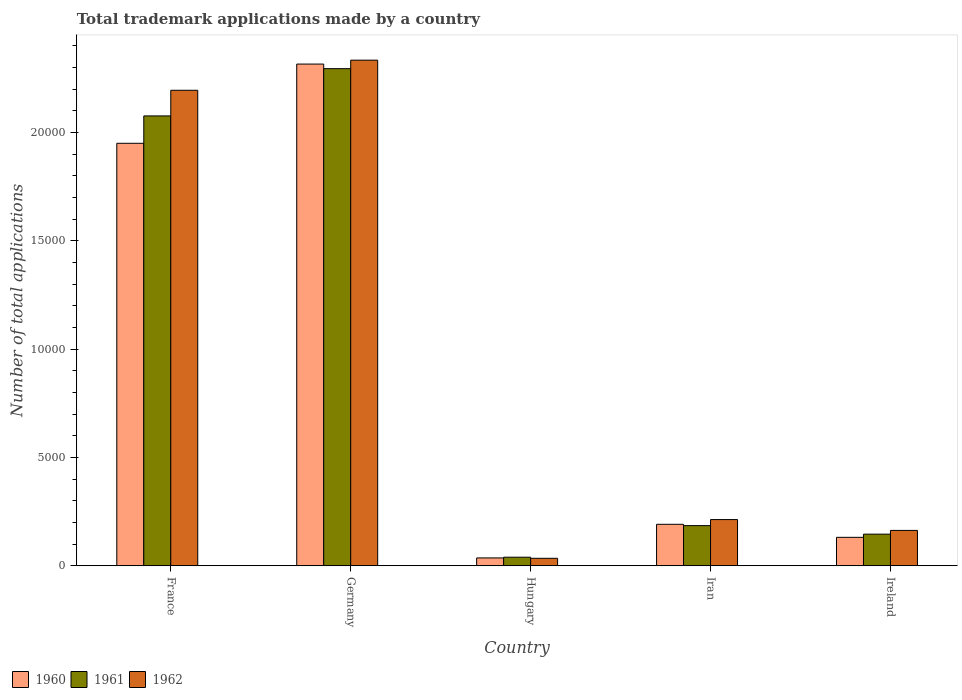How many different coloured bars are there?
Your answer should be very brief. 3. How many groups of bars are there?
Ensure brevity in your answer.  5. Are the number of bars on each tick of the X-axis equal?
Your answer should be compact. Yes. How many bars are there on the 2nd tick from the right?
Your answer should be very brief. 3. What is the number of applications made by in 1962 in Ireland?
Your response must be concise. 1633. Across all countries, what is the maximum number of applications made by in 1962?
Ensure brevity in your answer.  2.33e+04. Across all countries, what is the minimum number of applications made by in 1960?
Your response must be concise. 363. In which country was the number of applications made by in 1960 minimum?
Ensure brevity in your answer.  Hungary. What is the total number of applications made by in 1962 in the graph?
Provide a succinct answer. 4.94e+04. What is the difference between the number of applications made by in 1960 in Germany and that in Ireland?
Give a very brief answer. 2.18e+04. What is the difference between the number of applications made by in 1960 in Ireland and the number of applications made by in 1961 in France?
Ensure brevity in your answer.  -1.95e+04. What is the average number of applications made by in 1962 per country?
Make the answer very short. 9881.4. What is the difference between the number of applications made by of/in 1960 and number of applications made by of/in 1961 in Germany?
Offer a very short reply. 212. In how many countries, is the number of applications made by in 1960 greater than 15000?
Keep it short and to the point. 2. What is the ratio of the number of applications made by in 1962 in Hungary to that in Ireland?
Offer a terse response. 0.21. Is the number of applications made by in 1960 in Iran less than that in Ireland?
Your answer should be compact. No. Is the difference between the number of applications made by in 1960 in Germany and Ireland greater than the difference between the number of applications made by in 1961 in Germany and Ireland?
Your answer should be very brief. Yes. What is the difference between the highest and the second highest number of applications made by in 1961?
Your response must be concise. -2181. What is the difference between the highest and the lowest number of applications made by in 1960?
Provide a succinct answer. 2.28e+04. In how many countries, is the number of applications made by in 1962 greater than the average number of applications made by in 1962 taken over all countries?
Your answer should be very brief. 2. What does the 1st bar from the right in France represents?
Offer a terse response. 1962. Are all the bars in the graph horizontal?
Offer a very short reply. No. How many countries are there in the graph?
Your answer should be compact. 5. Are the values on the major ticks of Y-axis written in scientific E-notation?
Provide a succinct answer. No. Does the graph contain any zero values?
Your response must be concise. No. How many legend labels are there?
Offer a terse response. 3. How are the legend labels stacked?
Provide a succinct answer. Horizontal. What is the title of the graph?
Offer a very short reply. Total trademark applications made by a country. Does "1966" appear as one of the legend labels in the graph?
Your answer should be very brief. No. What is the label or title of the Y-axis?
Your response must be concise. Number of total applications. What is the Number of total applications in 1960 in France?
Give a very brief answer. 1.95e+04. What is the Number of total applications of 1961 in France?
Ensure brevity in your answer.  2.08e+04. What is the Number of total applications in 1962 in France?
Keep it short and to the point. 2.20e+04. What is the Number of total applications in 1960 in Germany?
Make the answer very short. 2.32e+04. What is the Number of total applications of 1961 in Germany?
Make the answer very short. 2.29e+04. What is the Number of total applications in 1962 in Germany?
Offer a terse response. 2.33e+04. What is the Number of total applications of 1960 in Hungary?
Ensure brevity in your answer.  363. What is the Number of total applications in 1961 in Hungary?
Your answer should be compact. 396. What is the Number of total applications of 1962 in Hungary?
Offer a terse response. 346. What is the Number of total applications of 1960 in Iran?
Your response must be concise. 1915. What is the Number of total applications of 1961 in Iran?
Offer a very short reply. 1854. What is the Number of total applications in 1962 in Iran?
Offer a terse response. 2134. What is the Number of total applications of 1960 in Ireland?
Your answer should be compact. 1314. What is the Number of total applications in 1961 in Ireland?
Give a very brief answer. 1461. What is the Number of total applications in 1962 in Ireland?
Offer a terse response. 1633. Across all countries, what is the maximum Number of total applications of 1960?
Ensure brevity in your answer.  2.32e+04. Across all countries, what is the maximum Number of total applications of 1961?
Offer a terse response. 2.29e+04. Across all countries, what is the maximum Number of total applications in 1962?
Offer a terse response. 2.33e+04. Across all countries, what is the minimum Number of total applications of 1960?
Give a very brief answer. 363. Across all countries, what is the minimum Number of total applications of 1961?
Your answer should be very brief. 396. Across all countries, what is the minimum Number of total applications in 1962?
Your response must be concise. 346. What is the total Number of total applications in 1960 in the graph?
Your answer should be compact. 4.63e+04. What is the total Number of total applications of 1961 in the graph?
Ensure brevity in your answer.  4.74e+04. What is the total Number of total applications in 1962 in the graph?
Keep it short and to the point. 4.94e+04. What is the difference between the Number of total applications in 1960 in France and that in Germany?
Offer a terse response. -3657. What is the difference between the Number of total applications of 1961 in France and that in Germany?
Your response must be concise. -2181. What is the difference between the Number of total applications of 1962 in France and that in Germany?
Offer a terse response. -1390. What is the difference between the Number of total applications in 1960 in France and that in Hungary?
Keep it short and to the point. 1.91e+04. What is the difference between the Number of total applications in 1961 in France and that in Hungary?
Provide a succinct answer. 2.04e+04. What is the difference between the Number of total applications of 1962 in France and that in Hungary?
Your answer should be very brief. 2.16e+04. What is the difference between the Number of total applications of 1960 in France and that in Iran?
Give a very brief answer. 1.76e+04. What is the difference between the Number of total applications of 1961 in France and that in Iran?
Your response must be concise. 1.89e+04. What is the difference between the Number of total applications in 1962 in France and that in Iran?
Give a very brief answer. 1.98e+04. What is the difference between the Number of total applications in 1960 in France and that in Ireland?
Keep it short and to the point. 1.82e+04. What is the difference between the Number of total applications in 1961 in France and that in Ireland?
Provide a short and direct response. 1.93e+04. What is the difference between the Number of total applications in 1962 in France and that in Ireland?
Your response must be concise. 2.03e+04. What is the difference between the Number of total applications of 1960 in Germany and that in Hungary?
Your answer should be compact. 2.28e+04. What is the difference between the Number of total applications in 1961 in Germany and that in Hungary?
Offer a very short reply. 2.26e+04. What is the difference between the Number of total applications of 1962 in Germany and that in Hungary?
Make the answer very short. 2.30e+04. What is the difference between the Number of total applications in 1960 in Germany and that in Iran?
Provide a succinct answer. 2.12e+04. What is the difference between the Number of total applications in 1961 in Germany and that in Iran?
Keep it short and to the point. 2.11e+04. What is the difference between the Number of total applications in 1962 in Germany and that in Iran?
Offer a very short reply. 2.12e+04. What is the difference between the Number of total applications of 1960 in Germany and that in Ireland?
Offer a terse response. 2.18e+04. What is the difference between the Number of total applications of 1961 in Germany and that in Ireland?
Your answer should be very brief. 2.15e+04. What is the difference between the Number of total applications of 1962 in Germany and that in Ireland?
Offer a very short reply. 2.17e+04. What is the difference between the Number of total applications of 1960 in Hungary and that in Iran?
Your response must be concise. -1552. What is the difference between the Number of total applications in 1961 in Hungary and that in Iran?
Offer a very short reply. -1458. What is the difference between the Number of total applications of 1962 in Hungary and that in Iran?
Provide a short and direct response. -1788. What is the difference between the Number of total applications in 1960 in Hungary and that in Ireland?
Ensure brevity in your answer.  -951. What is the difference between the Number of total applications in 1961 in Hungary and that in Ireland?
Provide a succinct answer. -1065. What is the difference between the Number of total applications of 1962 in Hungary and that in Ireland?
Your response must be concise. -1287. What is the difference between the Number of total applications in 1960 in Iran and that in Ireland?
Provide a succinct answer. 601. What is the difference between the Number of total applications in 1961 in Iran and that in Ireland?
Offer a terse response. 393. What is the difference between the Number of total applications in 1962 in Iran and that in Ireland?
Your response must be concise. 501. What is the difference between the Number of total applications in 1960 in France and the Number of total applications in 1961 in Germany?
Offer a very short reply. -3445. What is the difference between the Number of total applications of 1960 in France and the Number of total applications of 1962 in Germany?
Offer a terse response. -3838. What is the difference between the Number of total applications of 1961 in France and the Number of total applications of 1962 in Germany?
Provide a short and direct response. -2574. What is the difference between the Number of total applications of 1960 in France and the Number of total applications of 1961 in Hungary?
Provide a short and direct response. 1.91e+04. What is the difference between the Number of total applications in 1960 in France and the Number of total applications in 1962 in Hungary?
Your answer should be compact. 1.92e+04. What is the difference between the Number of total applications of 1961 in France and the Number of total applications of 1962 in Hungary?
Make the answer very short. 2.04e+04. What is the difference between the Number of total applications in 1960 in France and the Number of total applications in 1961 in Iran?
Provide a succinct answer. 1.76e+04. What is the difference between the Number of total applications of 1960 in France and the Number of total applications of 1962 in Iran?
Ensure brevity in your answer.  1.74e+04. What is the difference between the Number of total applications of 1961 in France and the Number of total applications of 1962 in Iran?
Give a very brief answer. 1.86e+04. What is the difference between the Number of total applications of 1960 in France and the Number of total applications of 1961 in Ireland?
Provide a succinct answer. 1.80e+04. What is the difference between the Number of total applications in 1960 in France and the Number of total applications in 1962 in Ireland?
Make the answer very short. 1.79e+04. What is the difference between the Number of total applications of 1961 in France and the Number of total applications of 1962 in Ireland?
Provide a succinct answer. 1.91e+04. What is the difference between the Number of total applications of 1960 in Germany and the Number of total applications of 1961 in Hungary?
Ensure brevity in your answer.  2.28e+04. What is the difference between the Number of total applications of 1960 in Germany and the Number of total applications of 1962 in Hungary?
Provide a short and direct response. 2.28e+04. What is the difference between the Number of total applications of 1961 in Germany and the Number of total applications of 1962 in Hungary?
Give a very brief answer. 2.26e+04. What is the difference between the Number of total applications in 1960 in Germany and the Number of total applications in 1961 in Iran?
Give a very brief answer. 2.13e+04. What is the difference between the Number of total applications of 1960 in Germany and the Number of total applications of 1962 in Iran?
Keep it short and to the point. 2.10e+04. What is the difference between the Number of total applications in 1961 in Germany and the Number of total applications in 1962 in Iran?
Provide a succinct answer. 2.08e+04. What is the difference between the Number of total applications in 1960 in Germany and the Number of total applications in 1961 in Ireland?
Provide a short and direct response. 2.17e+04. What is the difference between the Number of total applications of 1960 in Germany and the Number of total applications of 1962 in Ireland?
Give a very brief answer. 2.15e+04. What is the difference between the Number of total applications of 1961 in Germany and the Number of total applications of 1962 in Ireland?
Provide a succinct answer. 2.13e+04. What is the difference between the Number of total applications of 1960 in Hungary and the Number of total applications of 1961 in Iran?
Offer a terse response. -1491. What is the difference between the Number of total applications in 1960 in Hungary and the Number of total applications in 1962 in Iran?
Offer a very short reply. -1771. What is the difference between the Number of total applications of 1961 in Hungary and the Number of total applications of 1962 in Iran?
Make the answer very short. -1738. What is the difference between the Number of total applications in 1960 in Hungary and the Number of total applications in 1961 in Ireland?
Provide a short and direct response. -1098. What is the difference between the Number of total applications in 1960 in Hungary and the Number of total applications in 1962 in Ireland?
Your response must be concise. -1270. What is the difference between the Number of total applications in 1961 in Hungary and the Number of total applications in 1962 in Ireland?
Your response must be concise. -1237. What is the difference between the Number of total applications in 1960 in Iran and the Number of total applications in 1961 in Ireland?
Your answer should be compact. 454. What is the difference between the Number of total applications of 1960 in Iran and the Number of total applications of 1962 in Ireland?
Your response must be concise. 282. What is the difference between the Number of total applications of 1961 in Iran and the Number of total applications of 1962 in Ireland?
Give a very brief answer. 221. What is the average Number of total applications of 1960 per country?
Your response must be concise. 9251.4. What is the average Number of total applications in 1961 per country?
Offer a very short reply. 9485.6. What is the average Number of total applications in 1962 per country?
Give a very brief answer. 9881.4. What is the difference between the Number of total applications in 1960 and Number of total applications in 1961 in France?
Your answer should be very brief. -1264. What is the difference between the Number of total applications in 1960 and Number of total applications in 1962 in France?
Keep it short and to the point. -2448. What is the difference between the Number of total applications of 1961 and Number of total applications of 1962 in France?
Your answer should be compact. -1184. What is the difference between the Number of total applications of 1960 and Number of total applications of 1961 in Germany?
Give a very brief answer. 212. What is the difference between the Number of total applications of 1960 and Number of total applications of 1962 in Germany?
Make the answer very short. -181. What is the difference between the Number of total applications in 1961 and Number of total applications in 1962 in Germany?
Provide a short and direct response. -393. What is the difference between the Number of total applications in 1960 and Number of total applications in 1961 in Hungary?
Keep it short and to the point. -33. What is the difference between the Number of total applications of 1960 and Number of total applications of 1962 in Hungary?
Give a very brief answer. 17. What is the difference between the Number of total applications in 1960 and Number of total applications in 1961 in Iran?
Your answer should be compact. 61. What is the difference between the Number of total applications in 1960 and Number of total applications in 1962 in Iran?
Provide a short and direct response. -219. What is the difference between the Number of total applications of 1961 and Number of total applications of 1962 in Iran?
Your response must be concise. -280. What is the difference between the Number of total applications of 1960 and Number of total applications of 1961 in Ireland?
Give a very brief answer. -147. What is the difference between the Number of total applications of 1960 and Number of total applications of 1962 in Ireland?
Your answer should be compact. -319. What is the difference between the Number of total applications of 1961 and Number of total applications of 1962 in Ireland?
Provide a succinct answer. -172. What is the ratio of the Number of total applications of 1960 in France to that in Germany?
Your response must be concise. 0.84. What is the ratio of the Number of total applications in 1961 in France to that in Germany?
Keep it short and to the point. 0.91. What is the ratio of the Number of total applications in 1962 in France to that in Germany?
Your answer should be compact. 0.94. What is the ratio of the Number of total applications of 1960 in France to that in Hungary?
Provide a short and direct response. 53.73. What is the ratio of the Number of total applications in 1961 in France to that in Hungary?
Provide a short and direct response. 52.44. What is the ratio of the Number of total applications of 1962 in France to that in Hungary?
Offer a terse response. 63.45. What is the ratio of the Number of total applications of 1960 in France to that in Iran?
Offer a very short reply. 10.18. What is the ratio of the Number of total applications in 1961 in France to that in Iran?
Offer a terse response. 11.2. What is the ratio of the Number of total applications in 1962 in France to that in Iran?
Ensure brevity in your answer.  10.29. What is the ratio of the Number of total applications in 1960 in France to that in Ireland?
Offer a terse response. 14.84. What is the ratio of the Number of total applications of 1961 in France to that in Ireland?
Give a very brief answer. 14.21. What is the ratio of the Number of total applications of 1962 in France to that in Ireland?
Your answer should be very brief. 13.44. What is the ratio of the Number of total applications of 1960 in Germany to that in Hungary?
Provide a short and direct response. 63.8. What is the ratio of the Number of total applications in 1961 in Germany to that in Hungary?
Make the answer very short. 57.95. What is the ratio of the Number of total applications in 1962 in Germany to that in Hungary?
Give a very brief answer. 67.46. What is the ratio of the Number of total applications in 1960 in Germany to that in Iran?
Provide a short and direct response. 12.09. What is the ratio of the Number of total applications of 1961 in Germany to that in Iran?
Keep it short and to the point. 12.38. What is the ratio of the Number of total applications of 1962 in Germany to that in Iran?
Your answer should be compact. 10.94. What is the ratio of the Number of total applications in 1960 in Germany to that in Ireland?
Keep it short and to the point. 17.63. What is the ratio of the Number of total applications of 1961 in Germany to that in Ireland?
Your answer should be very brief. 15.71. What is the ratio of the Number of total applications of 1962 in Germany to that in Ireland?
Make the answer very short. 14.29. What is the ratio of the Number of total applications of 1960 in Hungary to that in Iran?
Your answer should be very brief. 0.19. What is the ratio of the Number of total applications in 1961 in Hungary to that in Iran?
Your answer should be very brief. 0.21. What is the ratio of the Number of total applications in 1962 in Hungary to that in Iran?
Provide a succinct answer. 0.16. What is the ratio of the Number of total applications of 1960 in Hungary to that in Ireland?
Offer a very short reply. 0.28. What is the ratio of the Number of total applications of 1961 in Hungary to that in Ireland?
Offer a very short reply. 0.27. What is the ratio of the Number of total applications in 1962 in Hungary to that in Ireland?
Offer a very short reply. 0.21. What is the ratio of the Number of total applications in 1960 in Iran to that in Ireland?
Provide a succinct answer. 1.46. What is the ratio of the Number of total applications in 1961 in Iran to that in Ireland?
Keep it short and to the point. 1.27. What is the ratio of the Number of total applications of 1962 in Iran to that in Ireland?
Give a very brief answer. 1.31. What is the difference between the highest and the second highest Number of total applications of 1960?
Make the answer very short. 3657. What is the difference between the highest and the second highest Number of total applications in 1961?
Your response must be concise. 2181. What is the difference between the highest and the second highest Number of total applications in 1962?
Provide a short and direct response. 1390. What is the difference between the highest and the lowest Number of total applications of 1960?
Your answer should be very brief. 2.28e+04. What is the difference between the highest and the lowest Number of total applications in 1961?
Offer a very short reply. 2.26e+04. What is the difference between the highest and the lowest Number of total applications in 1962?
Provide a short and direct response. 2.30e+04. 